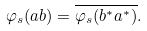<formula> <loc_0><loc_0><loc_500><loc_500>\varphi _ { s } ( a b ) = \overline { \varphi _ { s } ( b ^ { * } a ^ { * } ) } .</formula> 